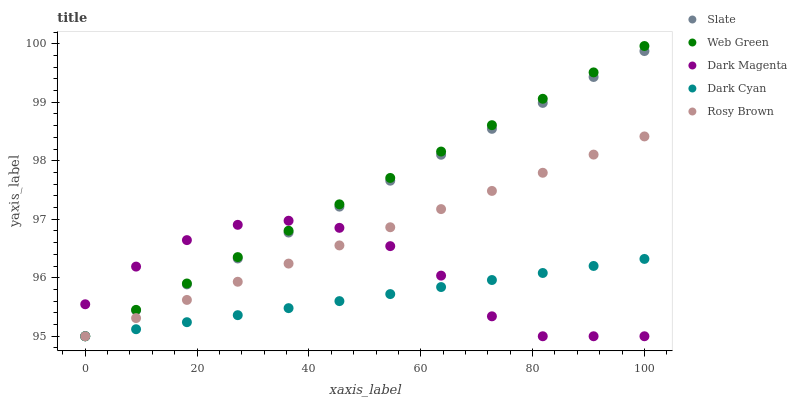Does Dark Cyan have the minimum area under the curve?
Answer yes or no. Yes. Does Web Green have the maximum area under the curve?
Answer yes or no. Yes. Does Slate have the minimum area under the curve?
Answer yes or no. No. Does Slate have the maximum area under the curve?
Answer yes or no. No. Is Slate the smoothest?
Answer yes or no. Yes. Is Dark Magenta the roughest?
Answer yes or no. Yes. Is Rosy Brown the smoothest?
Answer yes or no. No. Is Rosy Brown the roughest?
Answer yes or no. No. Does Dark Cyan have the lowest value?
Answer yes or no. Yes. Does Web Green have the highest value?
Answer yes or no. Yes. Does Slate have the highest value?
Answer yes or no. No. Does Rosy Brown intersect Dark Magenta?
Answer yes or no. Yes. Is Rosy Brown less than Dark Magenta?
Answer yes or no. No. Is Rosy Brown greater than Dark Magenta?
Answer yes or no. No. 